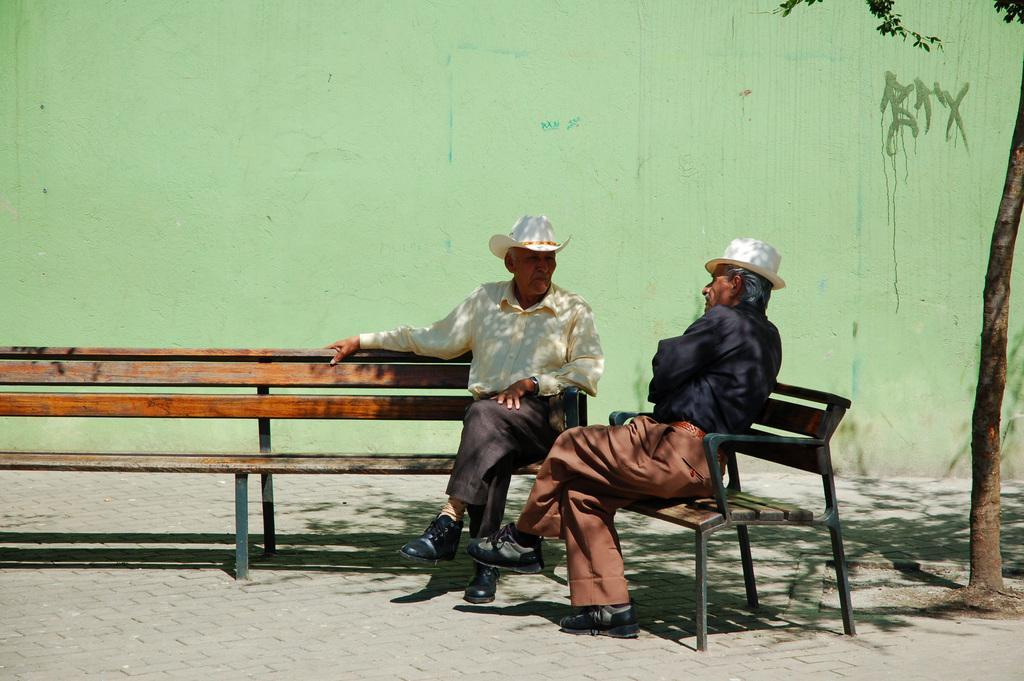Describe this image in one or two sentences. In this picture there are two men sitting on the benches, wearing hats. In the background there is wall and a tree here. 